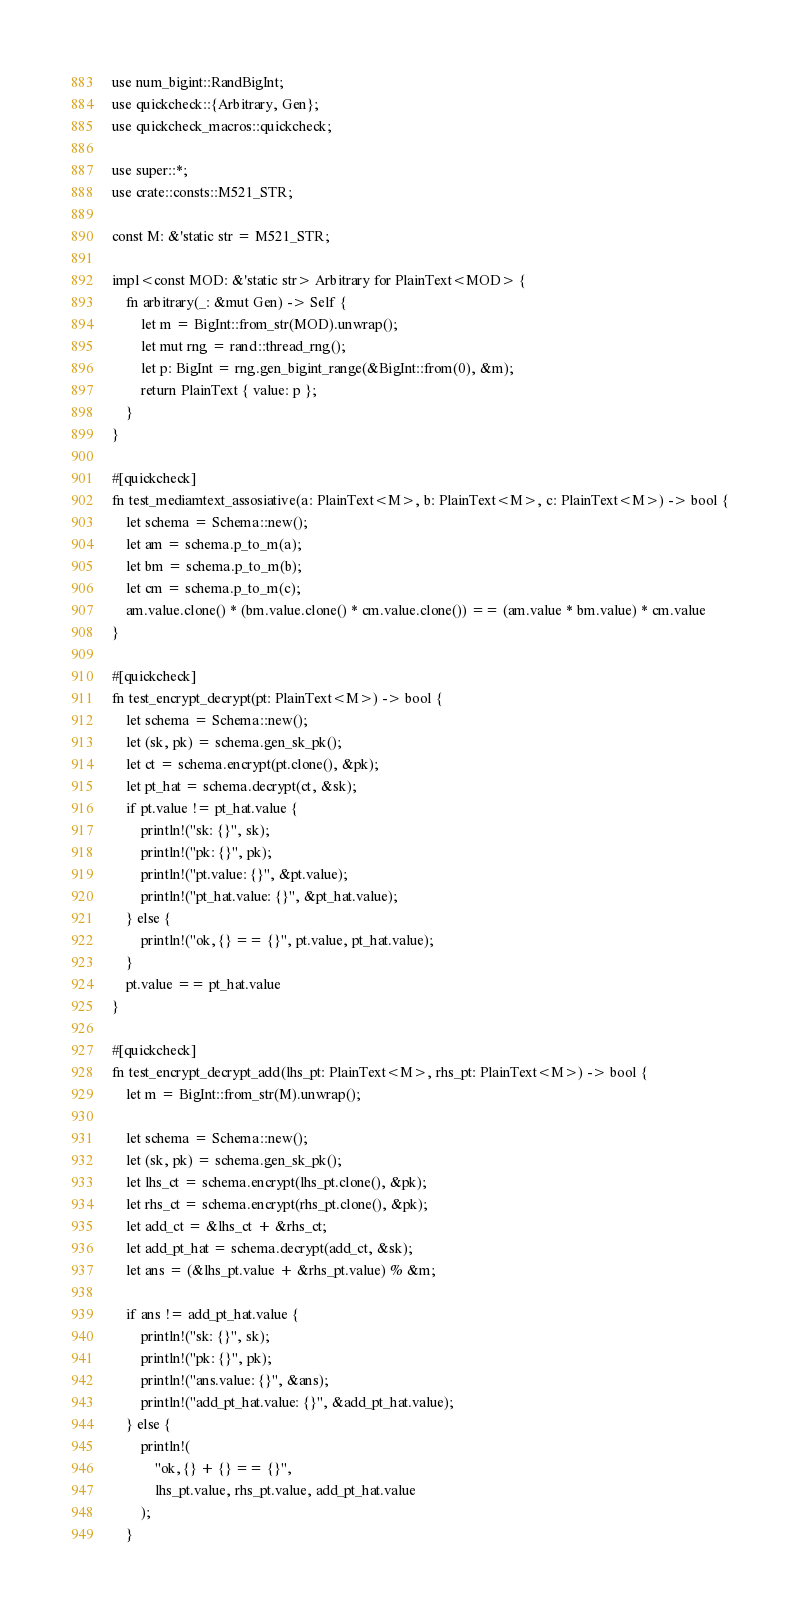<code> <loc_0><loc_0><loc_500><loc_500><_Rust_>use num_bigint::RandBigInt;
use quickcheck::{Arbitrary, Gen};
use quickcheck_macros::quickcheck;

use super::*;
use crate::consts::M521_STR;

const M: &'static str = M521_STR;

impl<const MOD: &'static str> Arbitrary for PlainText<MOD> {
    fn arbitrary(_: &mut Gen) -> Self {
        let m = BigInt::from_str(MOD).unwrap();
        let mut rng = rand::thread_rng();
        let p: BigInt = rng.gen_bigint_range(&BigInt::from(0), &m);
        return PlainText { value: p };
    }
}

#[quickcheck]
fn test_mediamtext_assosiative(a: PlainText<M>, b: PlainText<M>, c: PlainText<M>) -> bool {
    let schema = Schema::new();
    let am = schema.p_to_m(a);
    let bm = schema.p_to_m(b);
    let cm = schema.p_to_m(c);
    am.value.clone() * (bm.value.clone() * cm.value.clone()) == (am.value * bm.value) * cm.value
}

#[quickcheck]
fn test_encrypt_decrypt(pt: PlainText<M>) -> bool {
    let schema = Schema::new();
    let (sk, pk) = schema.gen_sk_pk();
    let ct = schema.encrypt(pt.clone(), &pk);
    let pt_hat = schema.decrypt(ct, &sk);
    if pt.value != pt_hat.value {
        println!("sk: {}", sk);
        println!("pk: {}", pk);
        println!("pt.value: {}", &pt.value);
        println!("pt_hat.value: {}", &pt_hat.value);
    } else {
        println!("ok, {} == {}", pt.value, pt_hat.value);
    }
    pt.value == pt_hat.value
}

#[quickcheck]
fn test_encrypt_decrypt_add(lhs_pt: PlainText<M>, rhs_pt: PlainText<M>) -> bool {
    let m = BigInt::from_str(M).unwrap();

    let schema = Schema::new();
    let (sk, pk) = schema.gen_sk_pk();
    let lhs_ct = schema.encrypt(lhs_pt.clone(), &pk);
    let rhs_ct = schema.encrypt(rhs_pt.clone(), &pk);
    let add_ct = &lhs_ct + &rhs_ct;
    let add_pt_hat = schema.decrypt(add_ct, &sk);
    let ans = (&lhs_pt.value + &rhs_pt.value) % &m;

    if ans != add_pt_hat.value {
        println!("sk: {}", sk);
        println!("pk: {}", pk);
        println!("ans.value: {}", &ans);
        println!("add_pt_hat.value: {}", &add_pt_hat.value);
    } else {
        println!(
            "ok, {} + {} == {}",
            lhs_pt.value, rhs_pt.value, add_pt_hat.value
        );
    }</code> 